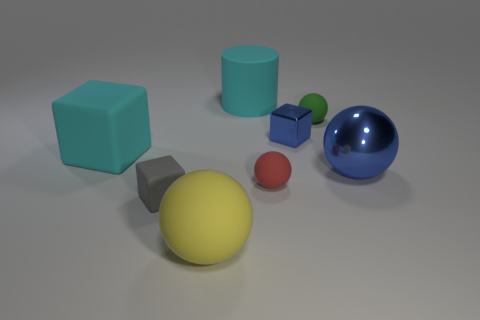What do the objects in the image suggest about the lighting source? Based on the shadows cast by the objects, with the shadows extending toward the bottom right, it suggests a light source positioned top left of the frame, likely implying a single, diffused light source given the softness of the shadows. 